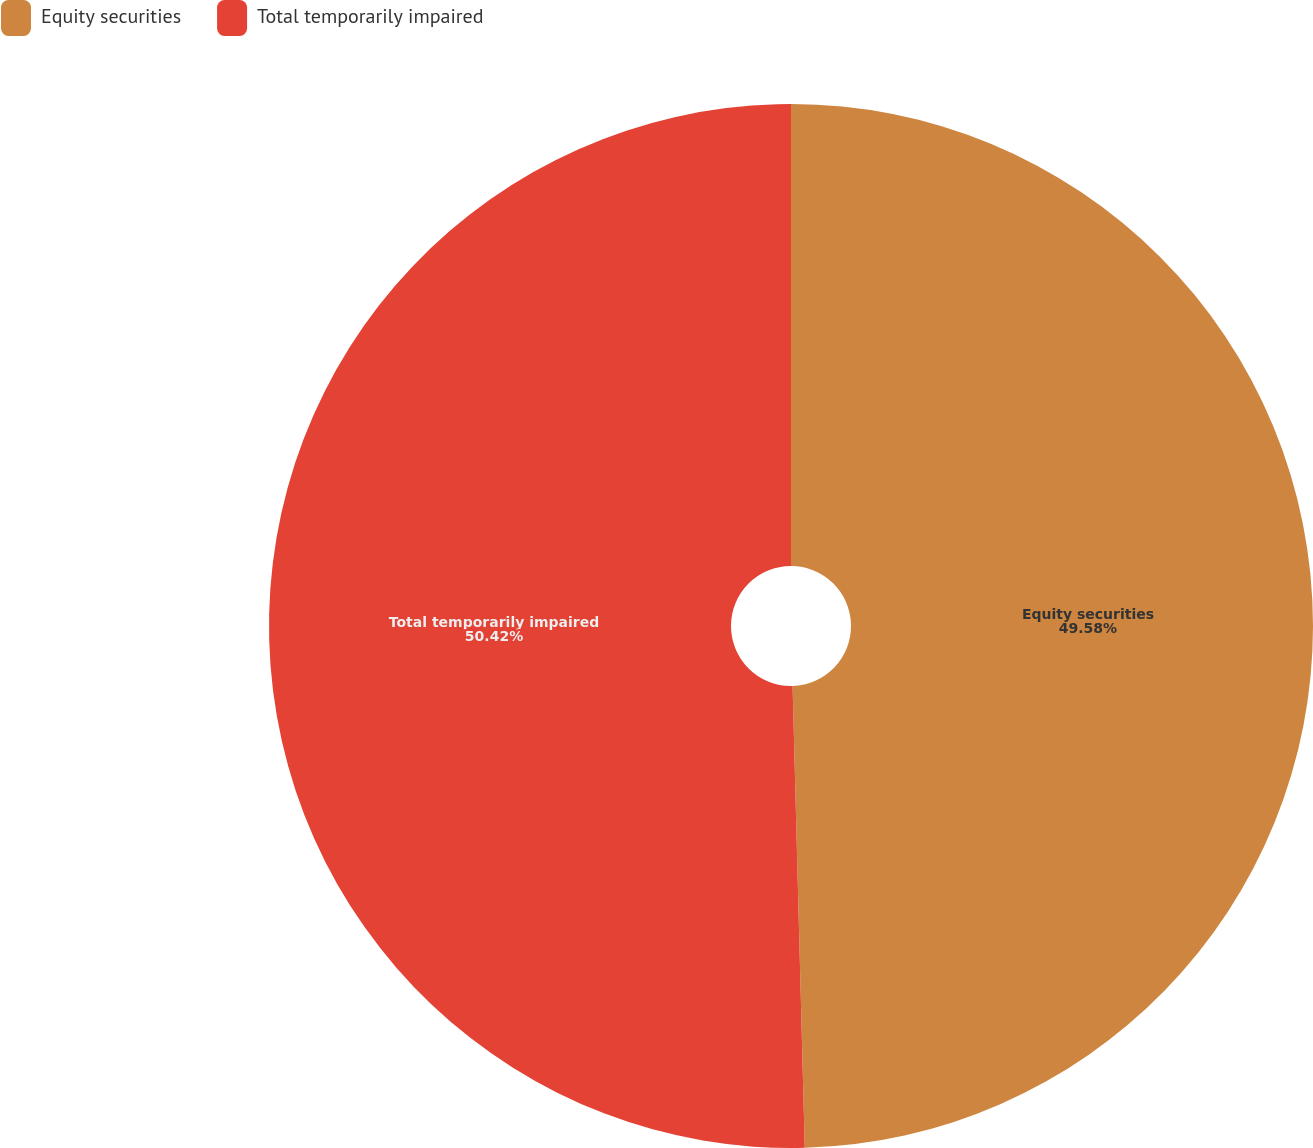Convert chart to OTSL. <chart><loc_0><loc_0><loc_500><loc_500><pie_chart><fcel>Equity securities<fcel>Total temporarily impaired<nl><fcel>49.58%<fcel>50.42%<nl></chart> 